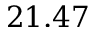<formula> <loc_0><loc_0><loc_500><loc_500>2 1 . 4 7</formula> 